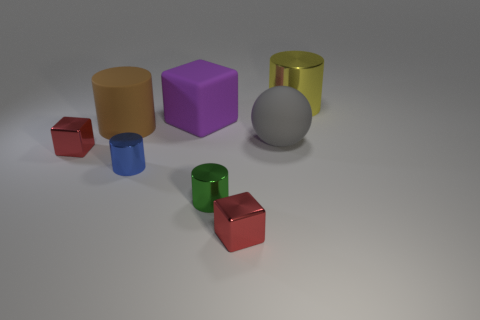Are there the same number of tiny blue cylinders that are behind the blue metallic thing and small matte balls?
Your response must be concise. Yes. There is a small blue cylinder; are there any yellow things in front of it?
Your answer should be compact. No. There is a purple object; is its shape the same as the object that is in front of the green metal thing?
Provide a succinct answer. Yes. There is a large cylinder that is the same material as the sphere; what is its color?
Offer a terse response. Brown. What is the color of the rubber sphere?
Give a very brief answer. Gray. Do the ball and the large cylinder in front of the big metal cylinder have the same material?
Ensure brevity in your answer.  Yes. What number of large cylinders are on the right side of the blue shiny thing and in front of the large yellow thing?
Give a very brief answer. 0. There is a metallic object that is the same size as the matte block; what shape is it?
Keep it short and to the point. Cylinder. Is there a small blue object on the right side of the block in front of the small block left of the blue cylinder?
Give a very brief answer. No. There is a ball; does it have the same color as the big thing that is to the left of the big purple block?
Keep it short and to the point. No. 